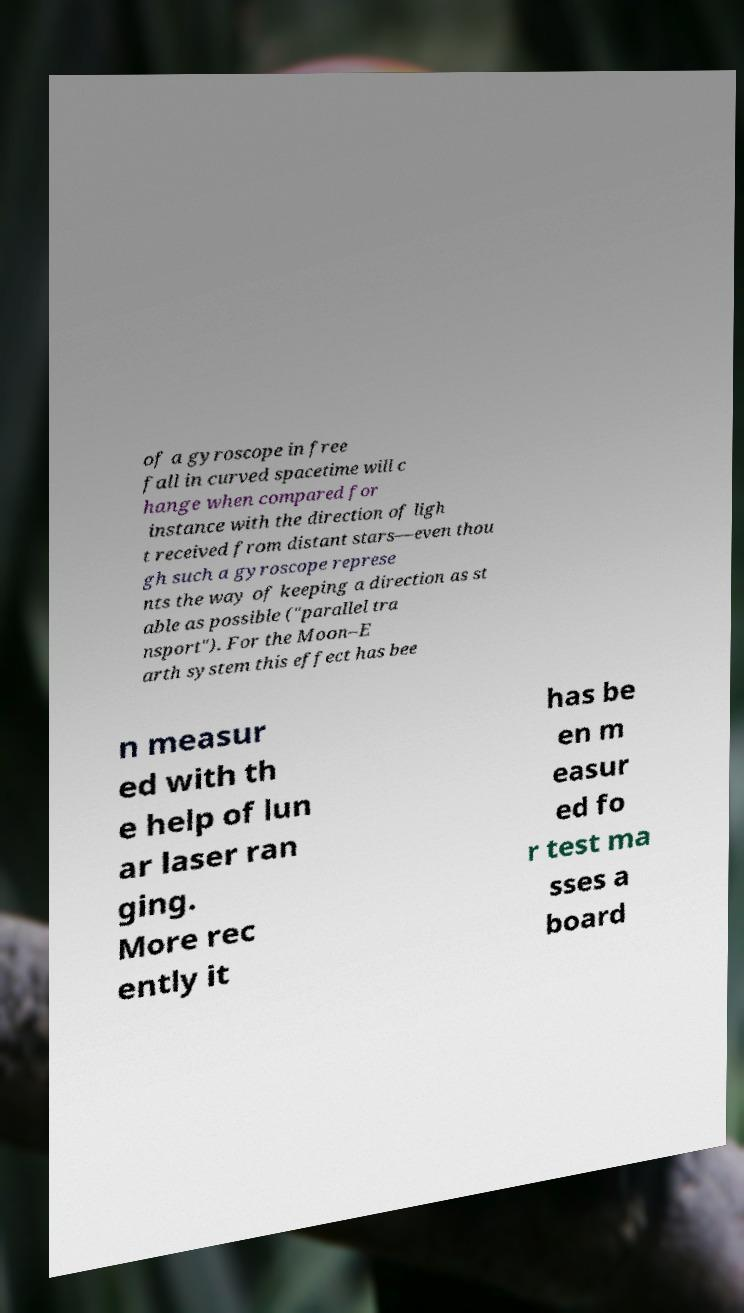There's text embedded in this image that I need extracted. Can you transcribe it verbatim? of a gyroscope in free fall in curved spacetime will c hange when compared for instance with the direction of ligh t received from distant stars—even thou gh such a gyroscope represe nts the way of keeping a direction as st able as possible ("parallel tra nsport"). For the Moon–E arth system this effect has bee n measur ed with th e help of lun ar laser ran ging. More rec ently it has be en m easur ed fo r test ma sses a board 